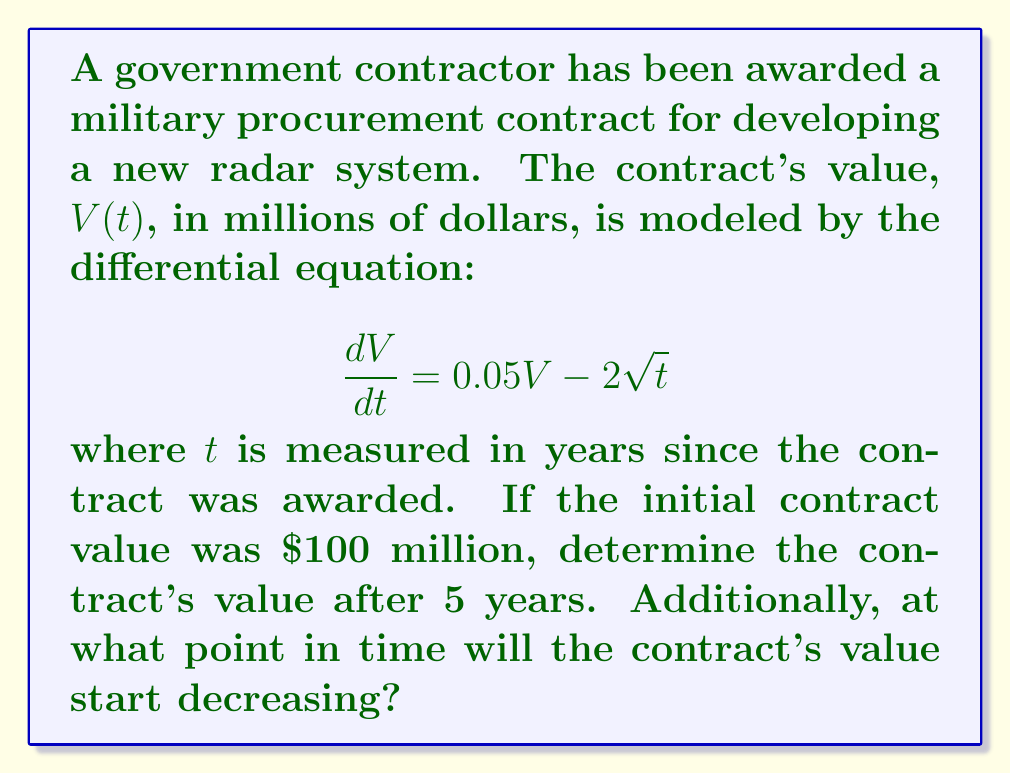Teach me how to tackle this problem. To solve this problem, we need to use techniques from differential equations:

1) First, we need to solve the given differential equation:
   $$\frac{dV}{dt} = 0.05V - 2\sqrt{t}$$

   This is a linear first-order differential equation.

2) The general solution for this type of equation is:
   $$V(t) = e^{0.05t}\left(C - \int 2\sqrt{t}e^{-0.05t}dt\right)$$
   where $C$ is a constant of integration.

3) To evaluate the integral, we can use integration by parts:
   $$\int 2\sqrt{t}e^{-0.05t}dt = -40\sqrt{t}e^{-0.05t} - 400\int \frac{e^{-0.05t}}{\sqrt{t}}dt$$

4) The last integral doesn't have an elementary antiderivative, but we can express it in terms of the error function:
   $$\int \frac{e^{-0.05t}}{\sqrt{t}}dt = \sqrt{\pi/0.05} \cdot \text{erf}(\sqrt{0.05t})$$

5) Substituting back, we get:
   $$V(t) = e^{0.05t}\left(C + 40\sqrt{t}e^{-0.05t} + 400\sqrt{\pi/0.05} \cdot \text{erf}(\sqrt{0.05t})\right)$$

6) To find $C$, we use the initial condition $V(0) = 100$:
   $$100 = C$$

7) Therefore, the specific solution is:
   $$V(t) = e^{0.05t}\left(100 + 40\sqrt{t}e^{-0.05t} + 400\sqrt{\pi/0.05} \cdot \text{erf}(\sqrt{0.05t})\right)$$

8) To find the value after 5 years, we substitute $t=5$:
   $$V(5) \approx 122.14$$ million dollars

9) To find when the contract's value starts decreasing, we need to find when $\frac{dV}{dt} = 0$:
   $$0.05V - 2\sqrt{t} = 0$$
   $$V = \frac{40\sqrt{t}}{1}$$

10) Substituting this back into our solution and solving numerically, we find:
    $$t \approx 16.47$$ years

Therefore, the contract's value will start decreasing after approximately 16.47 years.
Answer: The contract's value after 5 years will be approximately $122.14 million. The contract's value will start decreasing after approximately 16.47 years. 